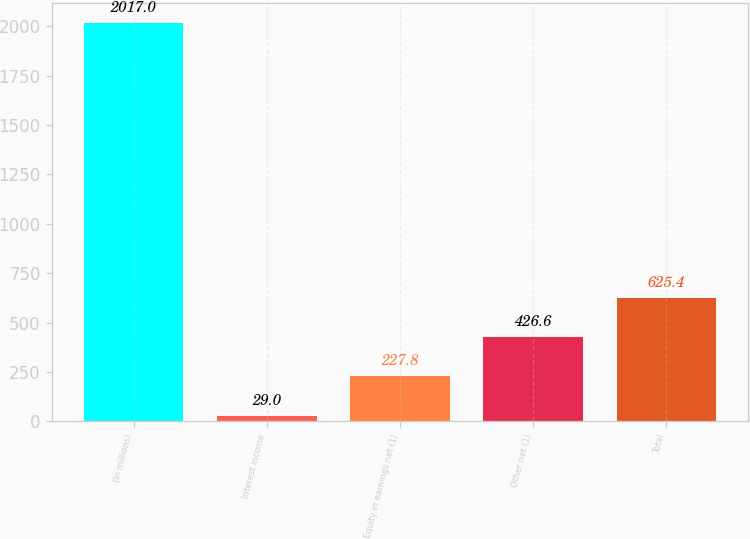<chart> <loc_0><loc_0><loc_500><loc_500><bar_chart><fcel>(In millions)<fcel>Interest income<fcel>Equity in earnings net (1)<fcel>Other net (1)<fcel>Total<nl><fcel>2017<fcel>29<fcel>227.8<fcel>426.6<fcel>625.4<nl></chart> 